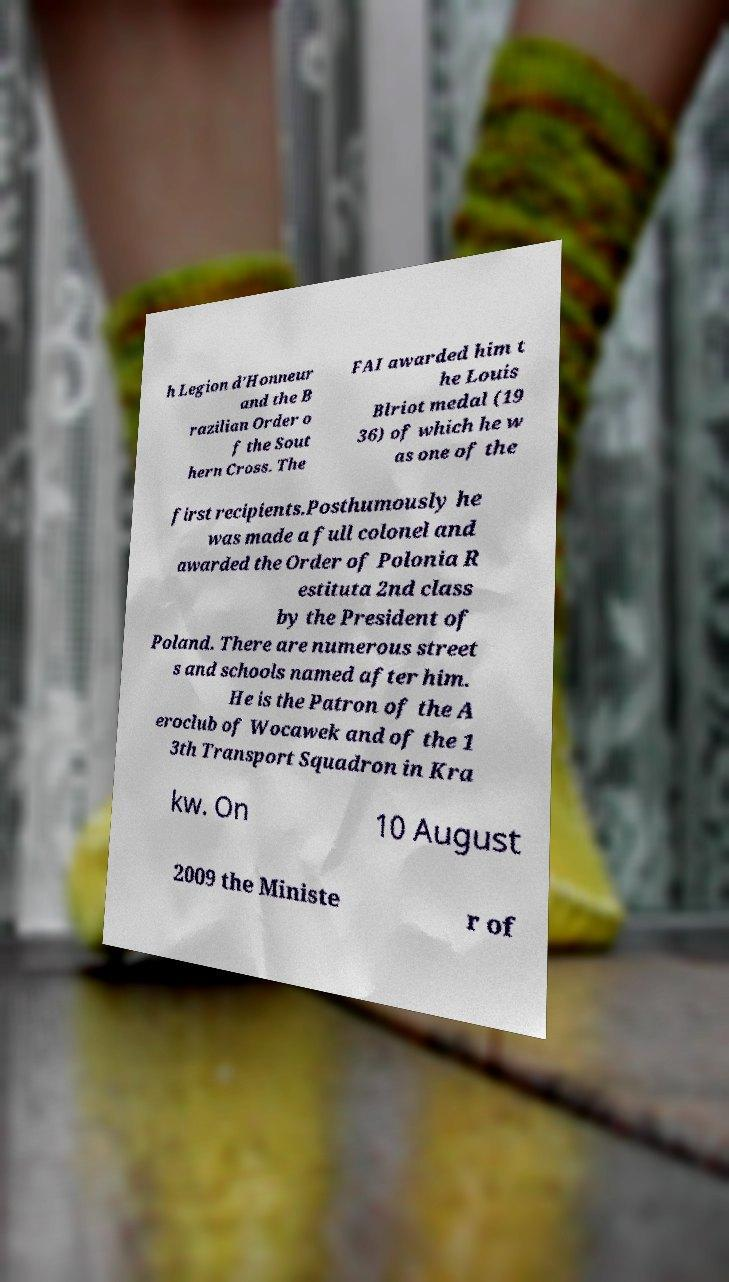Can you accurately transcribe the text from the provided image for me? h Legion d'Honneur and the B razilian Order o f the Sout hern Cross. The FAI awarded him t he Louis Blriot medal (19 36) of which he w as one of the first recipients.Posthumously he was made a full colonel and awarded the Order of Polonia R estituta 2nd class by the President of Poland. There are numerous street s and schools named after him. He is the Patron of the A eroclub of Wocawek and of the 1 3th Transport Squadron in Kra kw. On 10 August 2009 the Ministe r of 